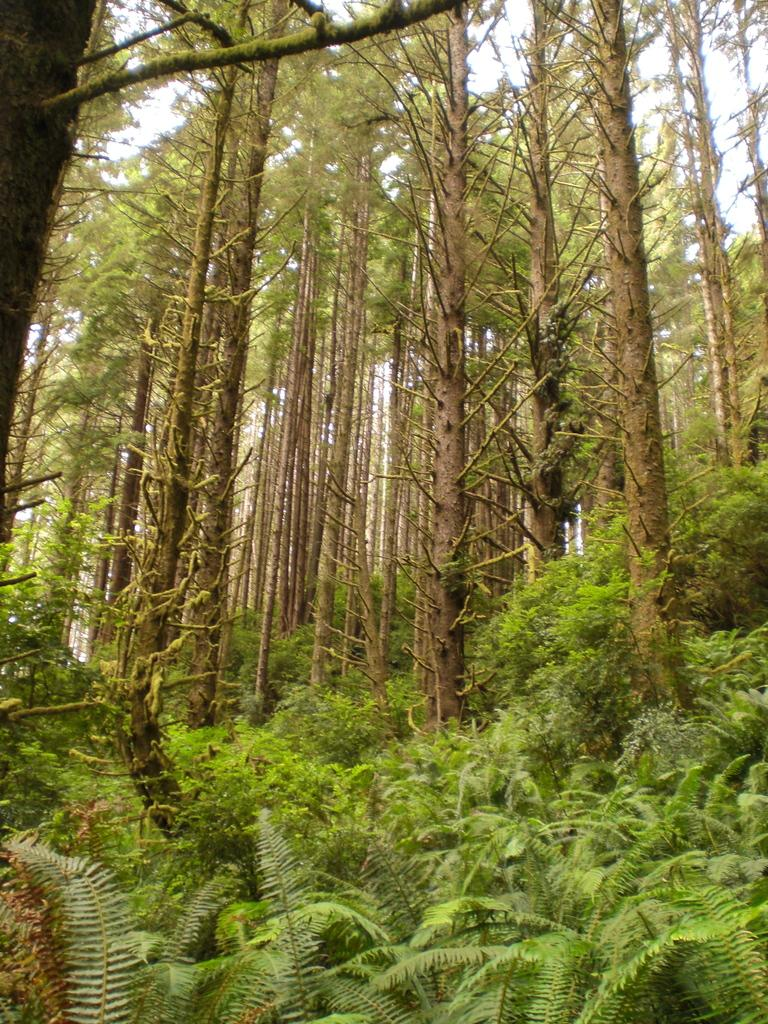What type of vegetation can be seen in the image? There are trees and plants in the image. Where are the plants located in the image? The plants are at the bottom of the image. What can be seen in the background of the image? The sky is visible in the background of the image. What type of stove is visible in the image? There is no stove present in the image. What color is the flag in the image? There is no flag present in the image. 